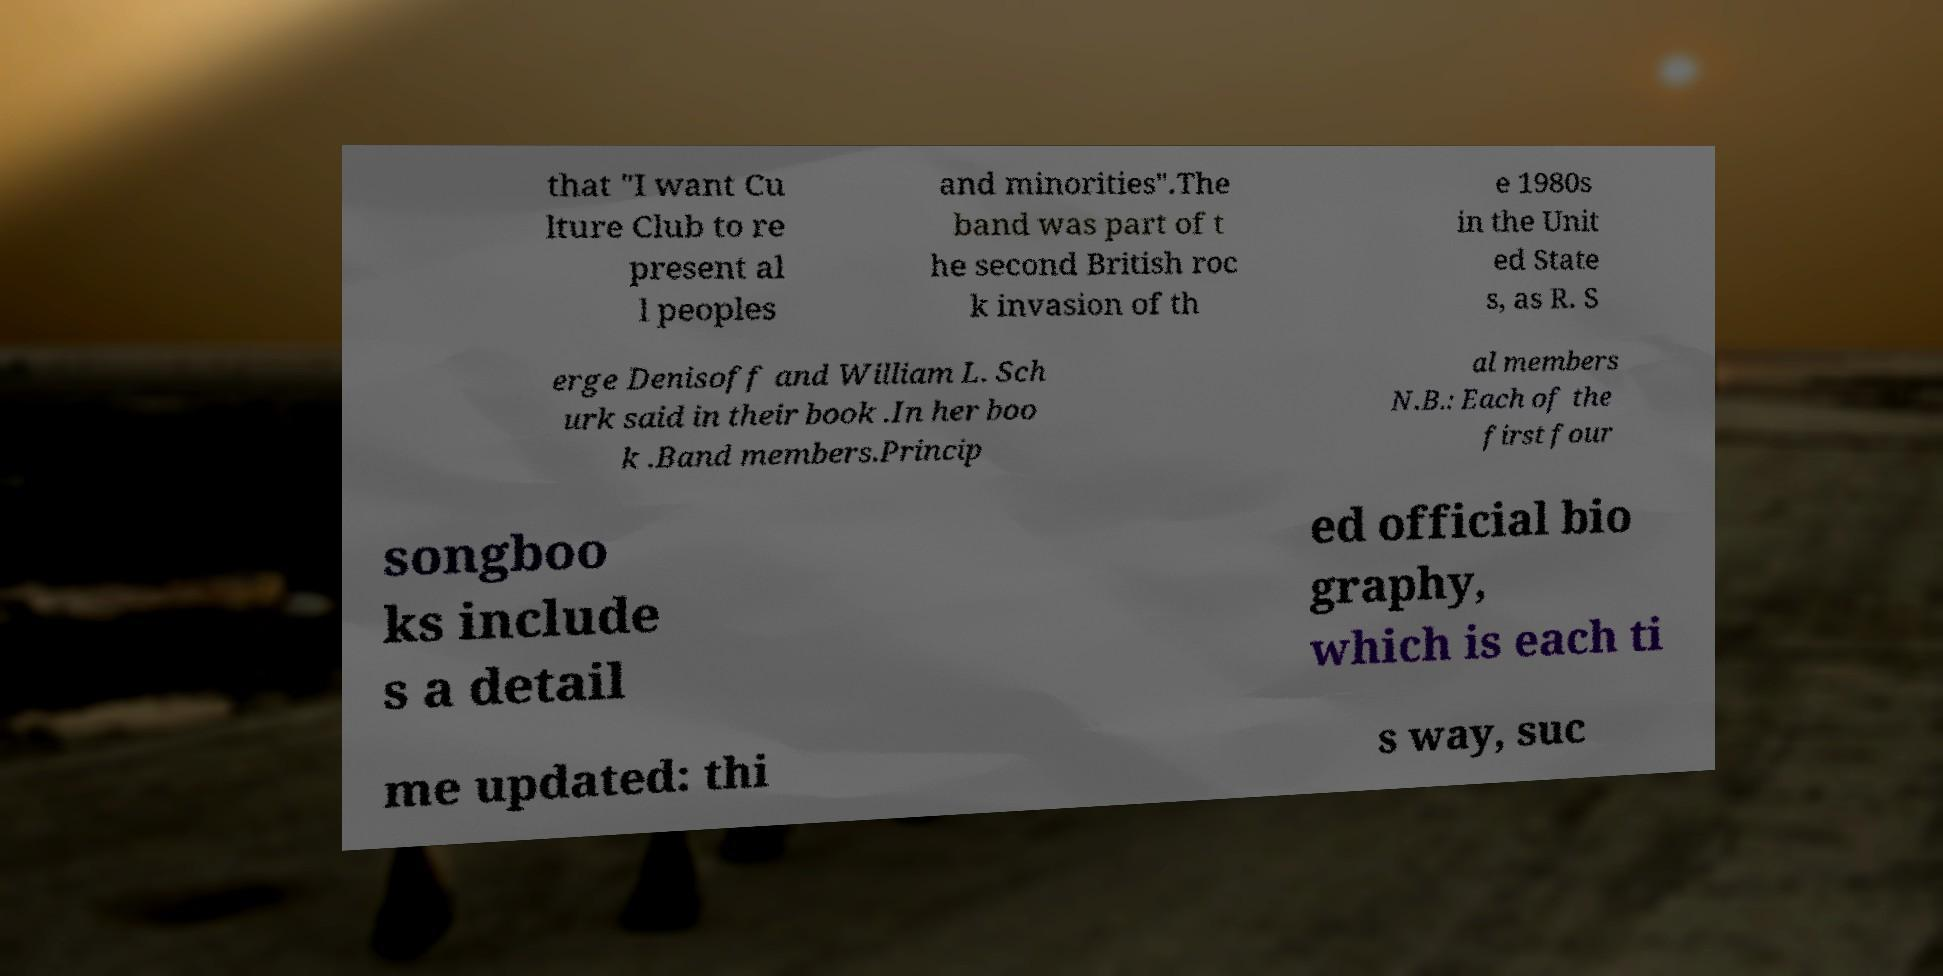I need the written content from this picture converted into text. Can you do that? that "I want Cu lture Club to re present al l peoples and minorities".The band was part of t he second British roc k invasion of th e 1980s in the Unit ed State s, as R. S erge Denisoff and William L. Sch urk said in their book .In her boo k .Band members.Princip al members N.B.: Each of the first four songboo ks include s a detail ed official bio graphy, which is each ti me updated: thi s way, suc 